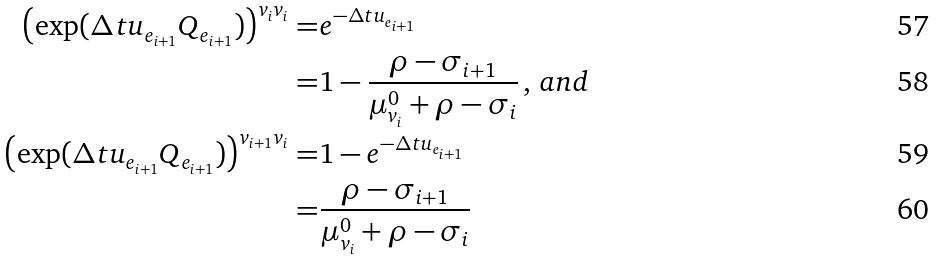Convert formula to latex. <formula><loc_0><loc_0><loc_500><loc_500>\left ( \exp ( \Delta t u _ { e _ { i + 1 } } Q _ { e _ { i + 1 } } ) \right ) ^ { v _ { i } v _ { i } } = & e ^ { - \Delta t u _ { e _ { i + 1 } } } \\ = & 1 - \frac { \rho - \sigma _ { i + 1 } } { \mu ^ { 0 } _ { v _ { i } } + \rho - \sigma _ { i } } \, , \, a n d \\ \left ( \exp ( \Delta t u _ { e _ { i + 1 } } Q _ { e _ { i + 1 } } ) \right ) ^ { v _ { i + 1 } v _ { i } } = & 1 - e ^ { - \Delta t u _ { e _ { i + 1 } } } \\ = & \frac { \rho - \sigma _ { i + 1 } } { \mu ^ { 0 } _ { v _ { i } } + \rho - \sigma _ { i } }</formula> 